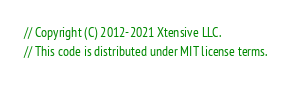Convert code to text. <code><loc_0><loc_0><loc_500><loc_500><_C#_>// Copyright (C) 2012-2021 Xtensive LLC.
// This code is distributed under MIT license terms.</code> 